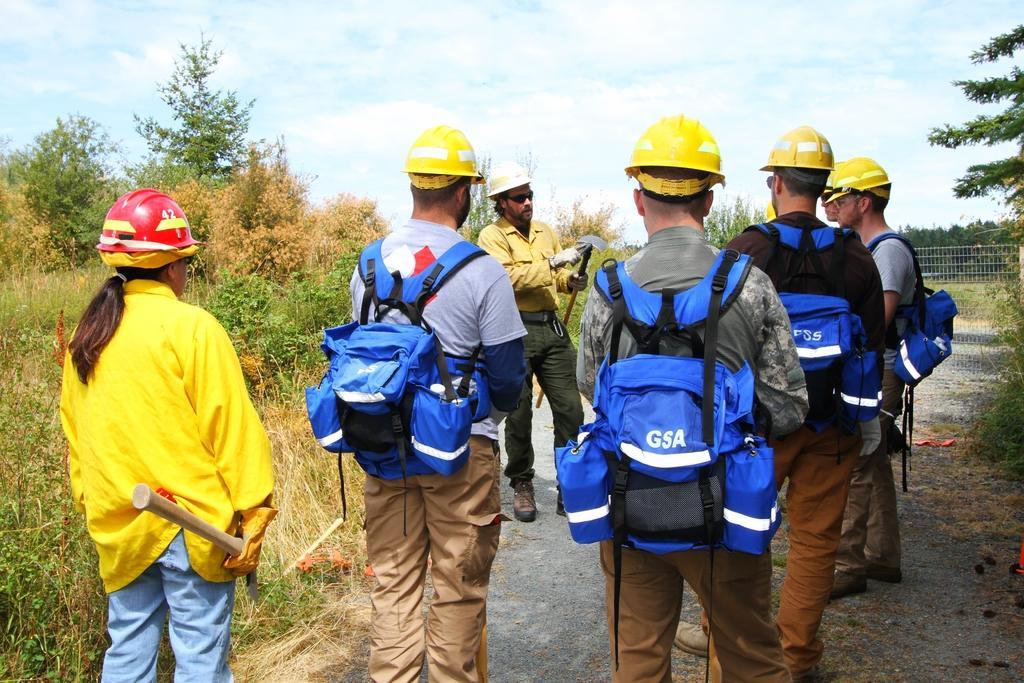In one or two sentences, can you explain what this image depicts? In the picture we can see some people are standing on the road, wearing the bags and helmets and beside them, we can see the grass plants and in the background we can see the sky with clouds. 